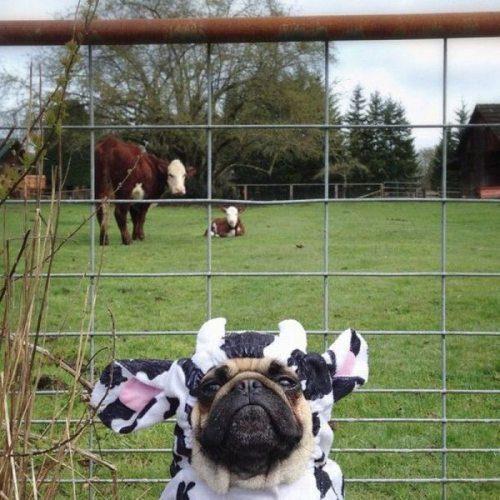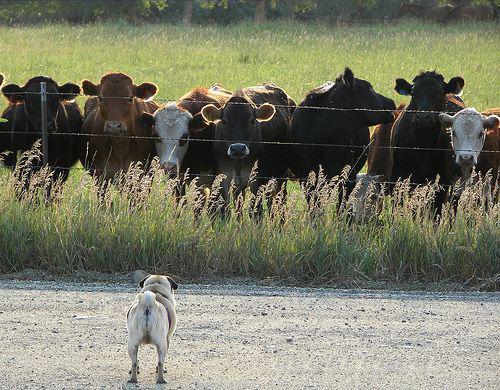The first image is the image on the left, the second image is the image on the right. Evaluate the accuracy of this statement regarding the images: "The left image includes a dog wearing a black and white cow print costume.". Is it true? Answer yes or no. Yes. The first image is the image on the left, the second image is the image on the right. For the images displayed, is the sentence "The dogs on the left are dressed like cows." factually correct? Answer yes or no. Yes. 